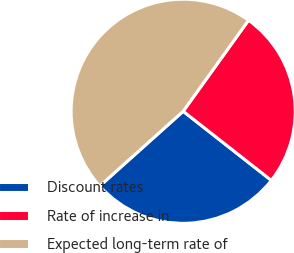Convert chart to OTSL. <chart><loc_0><loc_0><loc_500><loc_500><pie_chart><fcel>Discount rates<fcel>Rate of increase in<fcel>Expected long-term rate of<nl><fcel>27.79%<fcel>25.67%<fcel>46.53%<nl></chart> 